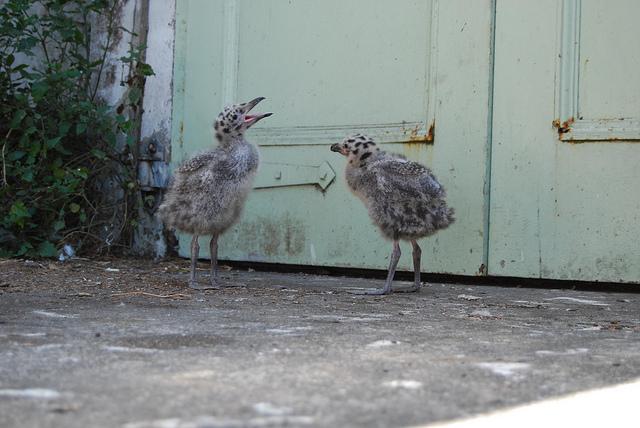How many birds are here?
Be succinct. 2. Are the birds young?
Concise answer only. Yes. What color is the door?
Short answer required. White. How many birds are the same color?
Be succinct. 2. How many birds?
Write a very short answer. 2. Are both bird's mouths open?
Give a very brief answer. No. 